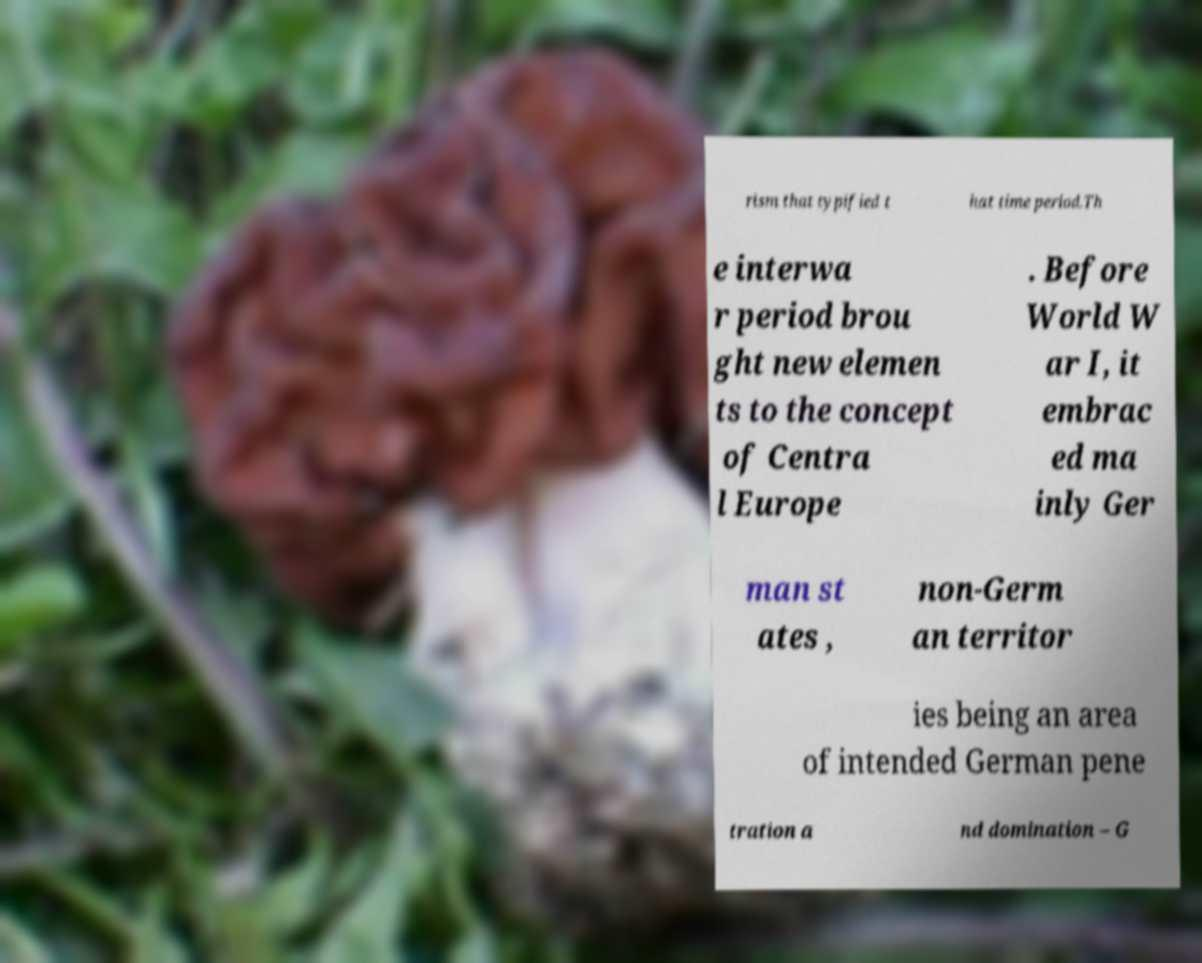Can you accurately transcribe the text from the provided image for me? rism that typified t hat time period.Th e interwa r period brou ght new elemen ts to the concept of Centra l Europe . Before World W ar I, it embrac ed ma inly Ger man st ates , non-Germ an territor ies being an area of intended German pene tration a nd domination – G 